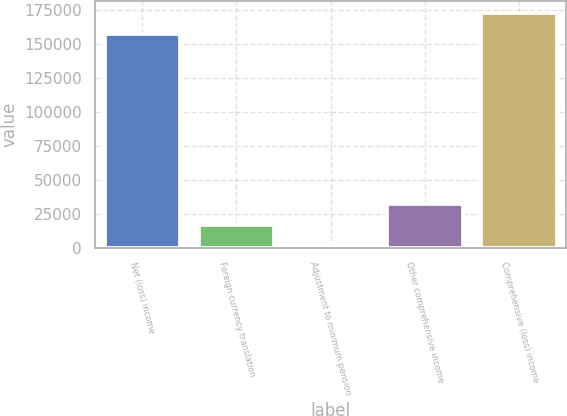Convert chart. <chart><loc_0><loc_0><loc_500><loc_500><bar_chart><fcel>Net (loss) income<fcel>Foreign currency translation<fcel>Adjustment to minimum pension<fcel>Other comprehensive income<fcel>Comprehensive (loss) income<nl><fcel>157150<fcel>16587.8<fcel>764<fcel>32411.6<fcel>172974<nl></chart> 